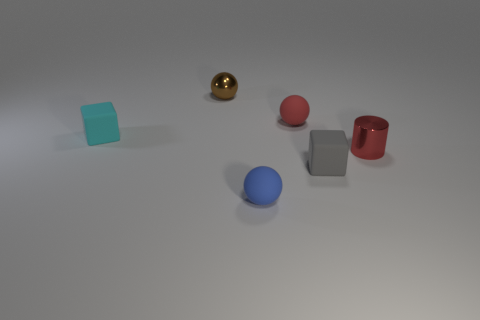Add 3 tiny gray blocks. How many objects exist? 9 Subtract all small blue spheres. How many spheres are left? 2 Subtract all blue spheres. How many spheres are left? 2 Subtract 2 spheres. How many spheres are left? 1 Add 3 cyan objects. How many cyan objects exist? 4 Subtract 0 purple balls. How many objects are left? 6 Subtract all cylinders. How many objects are left? 5 Subtract all brown spheres. Subtract all green blocks. How many spheres are left? 2 Subtract all purple cylinders. How many blue balls are left? 1 Subtract all big purple shiny cylinders. Subtract all blue rubber spheres. How many objects are left? 5 